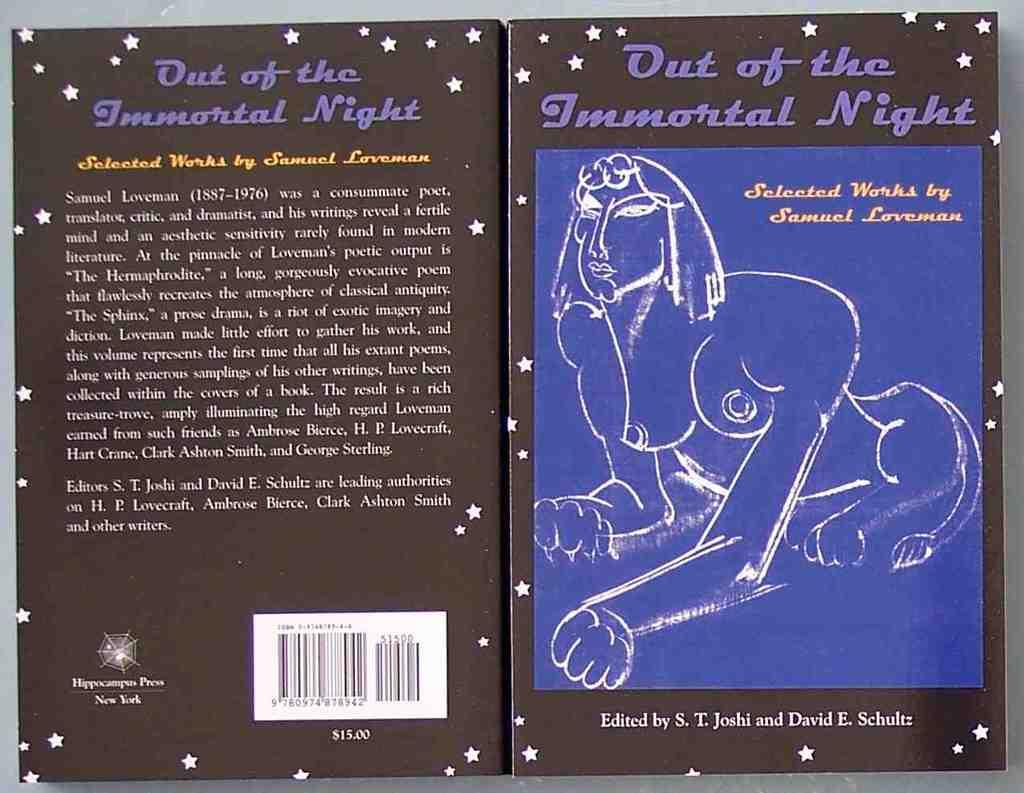Who are the editors of the book ?
Keep it short and to the point. S. t. joshi and david e. schultz. Is the book about gods and an endless night?
Offer a very short reply. Unanswerable. 